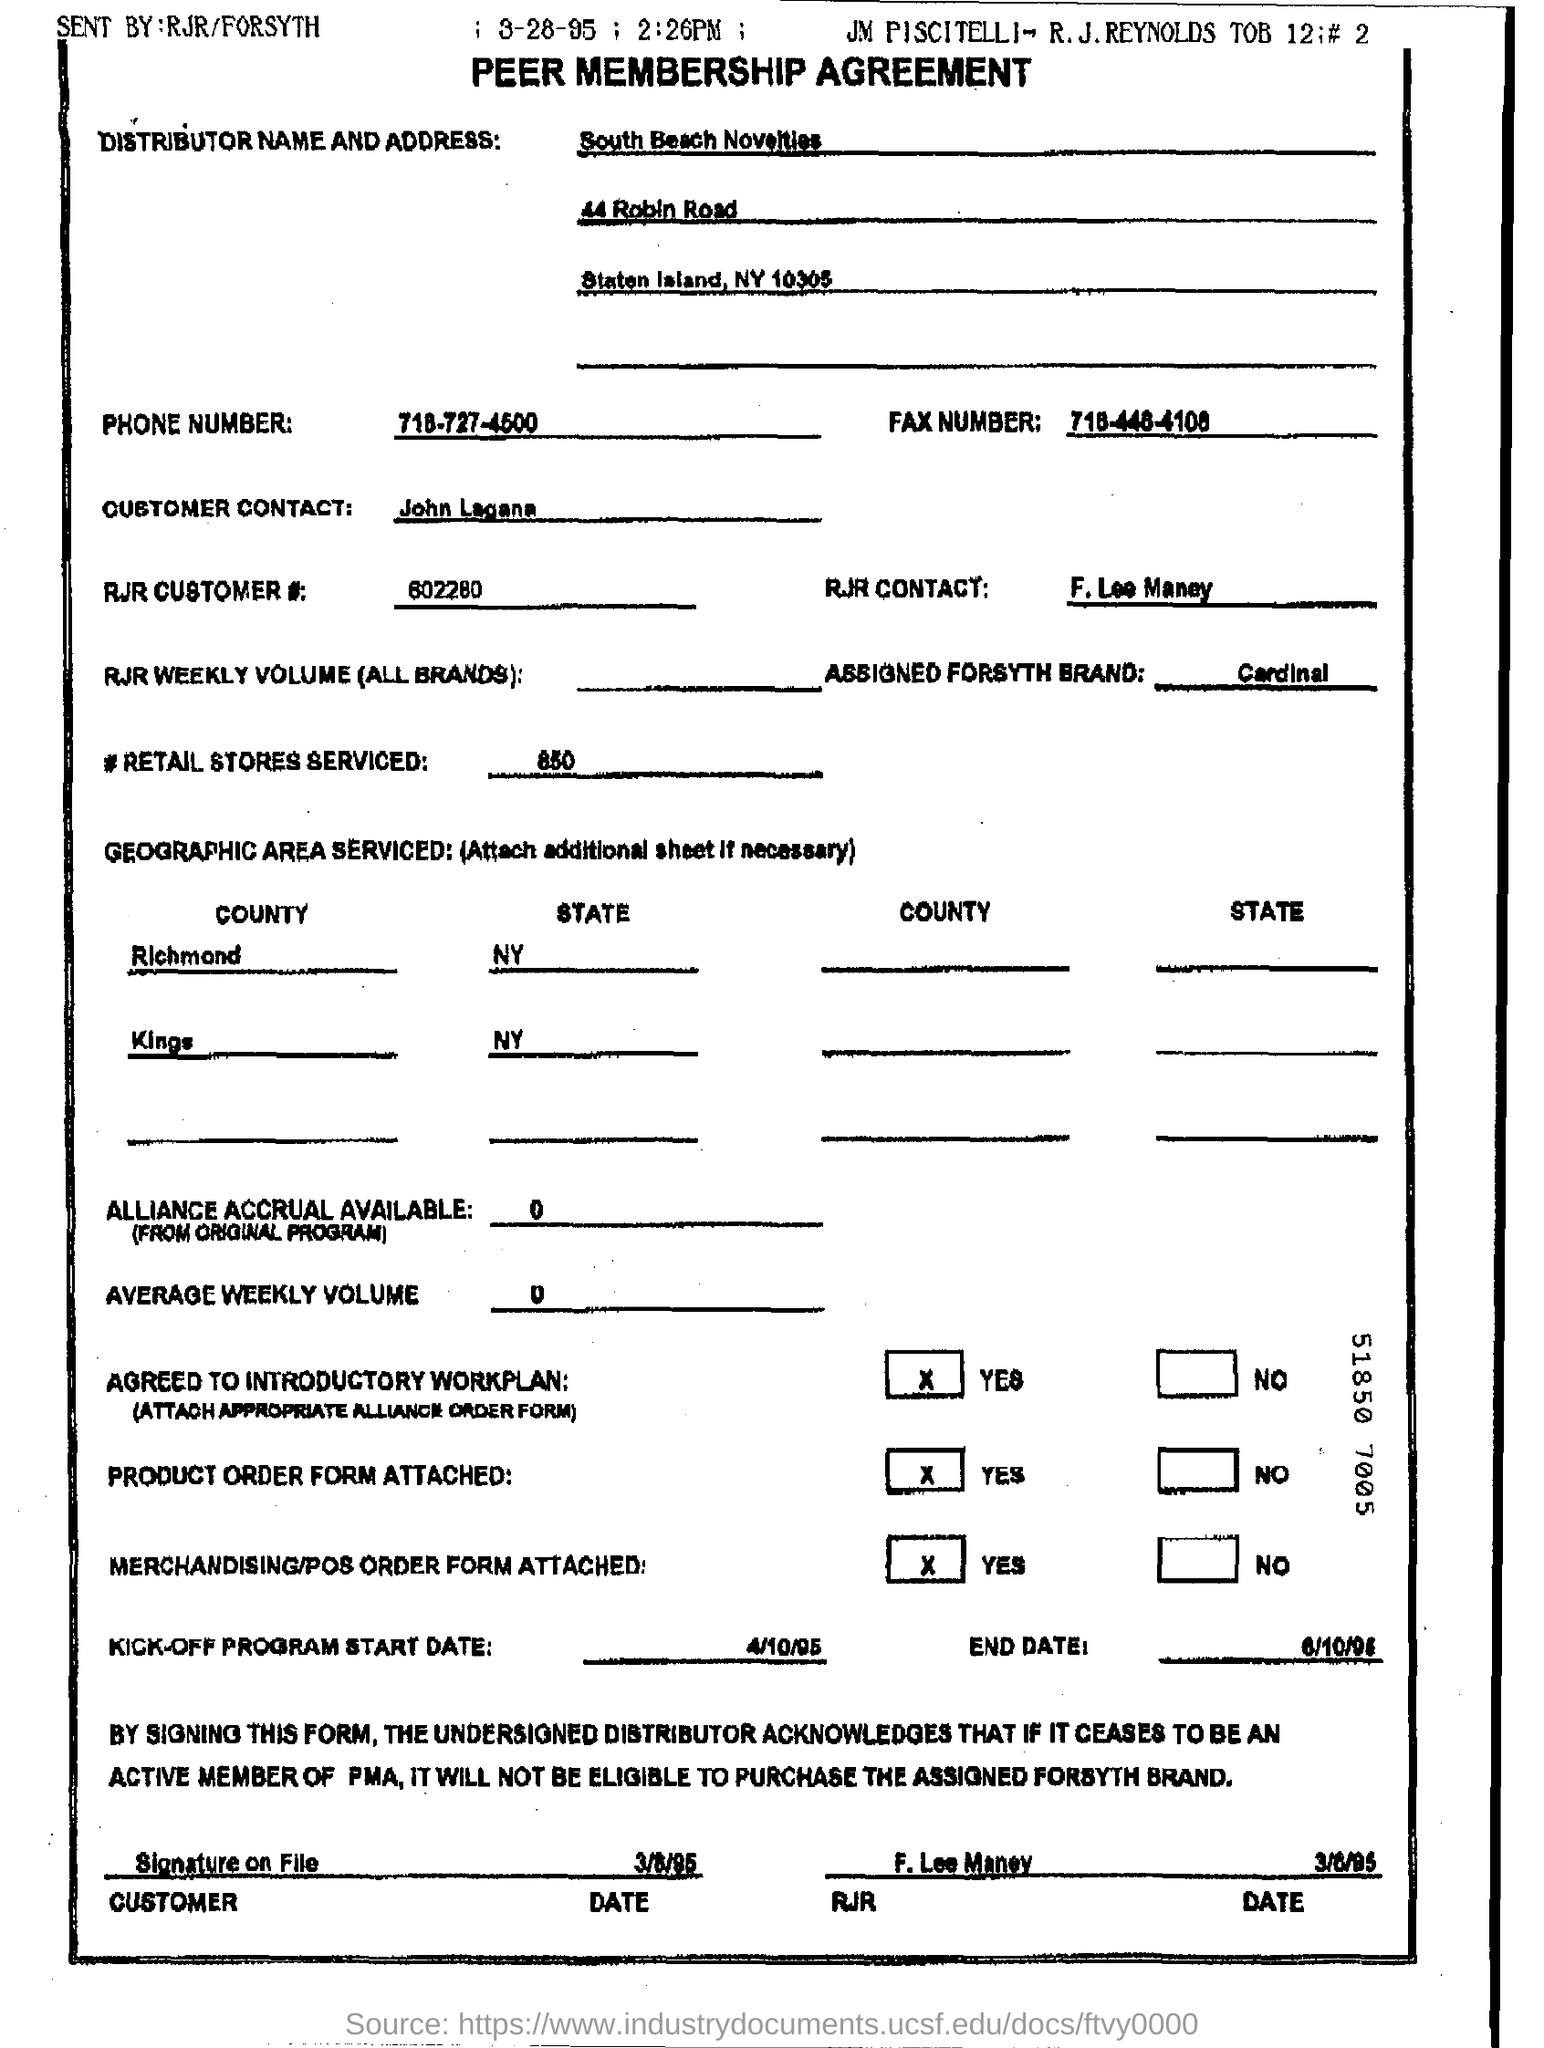What is the distributor name?
Your response must be concise. South beach novelties. Who sent the agreement?
Offer a very short reply. RJR/FORSYTH. What is RJR customer number?
Your answer should be very brief. 602280. Which is the assigned FORSYTH Brand?
Offer a terse response. Cardinal. How many retail stores were serviced?
Give a very brief answer. 850. When will kick-off program start?
Give a very brief answer. 4/10/95. 